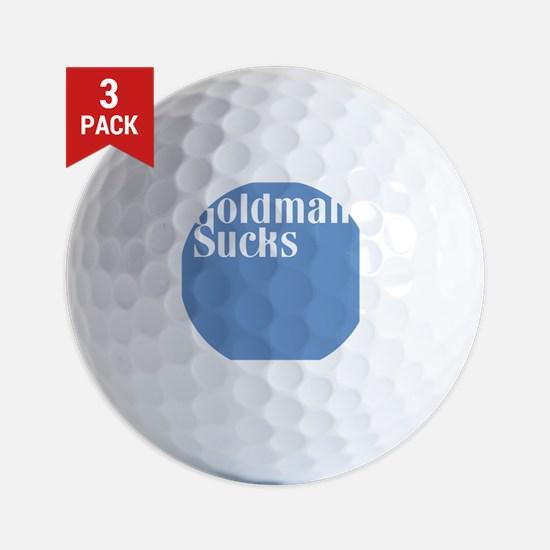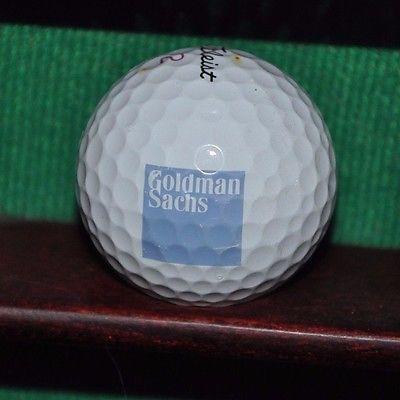The first image is the image on the left, the second image is the image on the right. Analyze the images presented: Is the assertion "In the image to the right the golfball has a design that is square shaped." valid? Answer yes or no. Yes. 